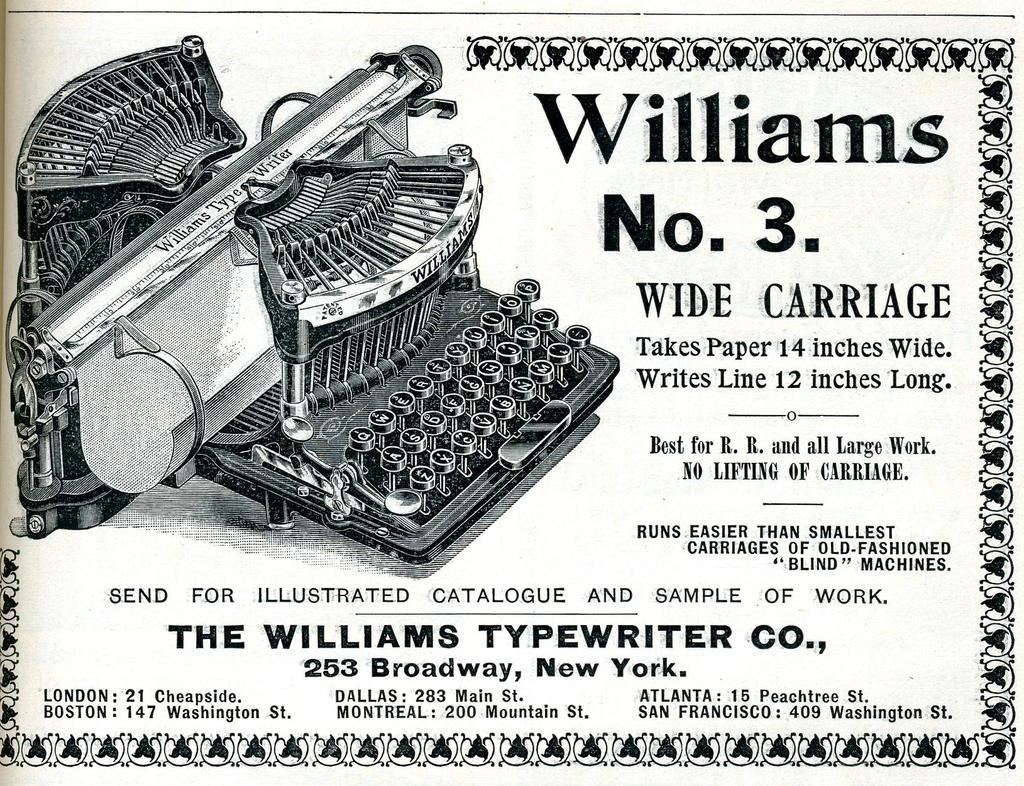<image>
Share a concise interpretation of the image provided. An advertisment poster for Williams No 3 from The Williams Typewriter Co 